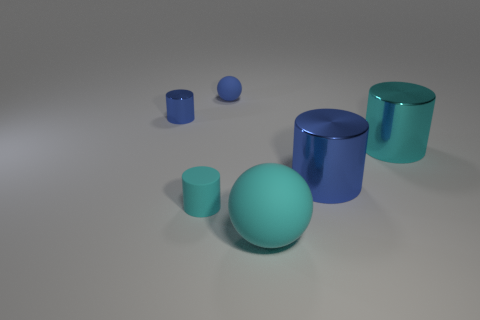Is the tiny blue thing that is on the right side of the tiny blue cylinder made of the same material as the tiny cyan cylinder?
Keep it short and to the point. Yes. There is a tiny rubber thing in front of the large cyan metal object; what is its color?
Offer a very short reply. Cyan. Is there a purple ball that has the same size as the cyan metallic cylinder?
Give a very brief answer. No. There is a cyan thing that is the same size as the blue matte thing; what is its material?
Your answer should be very brief. Rubber. Is the size of the cyan rubber cylinder the same as the rubber thing behind the large blue object?
Offer a terse response. Yes. What is the material of the ball left of the cyan ball?
Offer a very short reply. Rubber. Are there an equal number of large blue shiny cylinders to the left of the large blue metal cylinder and large brown rubber balls?
Provide a succinct answer. Yes. Is the blue ball the same size as the cyan metallic cylinder?
Your response must be concise. No. Are there any blue things that are in front of the ball that is behind the large cyan thing that is on the left side of the large blue shiny cylinder?
Offer a terse response. Yes. What material is the other object that is the same shape as the blue rubber object?
Offer a very short reply. Rubber. 